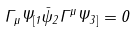<formula> <loc_0><loc_0><loc_500><loc_500>\Gamma _ { \mu } \Psi _ { [ 1 } \bar { \psi } _ { 2 } \Gamma ^ { \mu } \Psi _ { 3 ] } = 0</formula> 